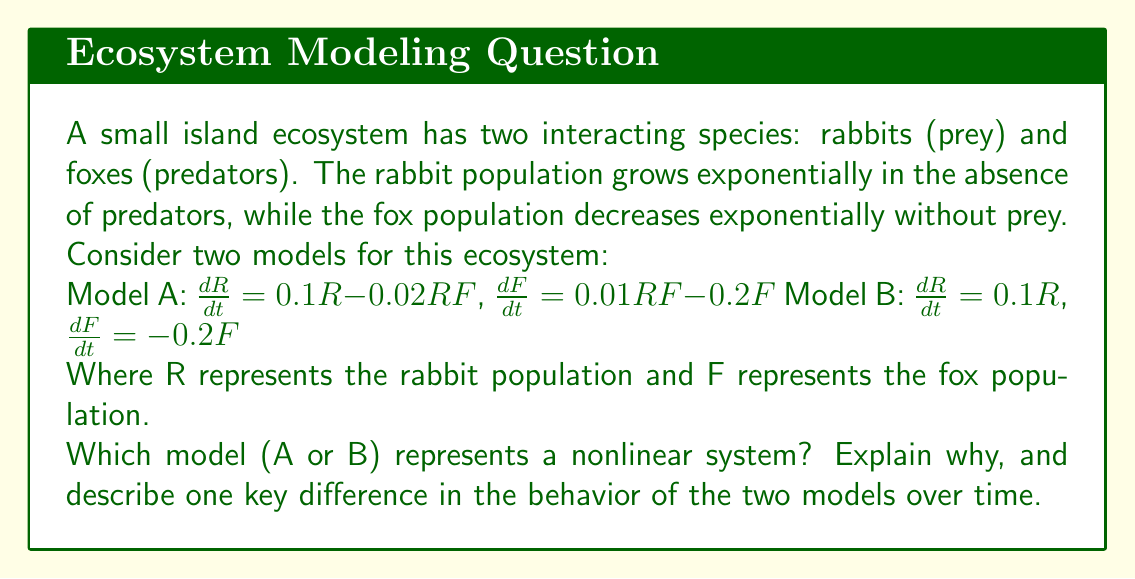Can you answer this question? To answer this question, let's analyze both models:

1. Model A:
   $\frac{dR}{dt} = 0.1R - 0.02RF$
   $\frac{dF}{dt} = 0.01RF - 0.2F$

   This system is nonlinear because it contains terms where variables are multiplied together (RF). The presence of these nonlinear terms makes the system more complex.

2. Model B:
   $\frac{dR}{dt} = 0.1R$
   $\frac{dF}{dt} = -0.2F$

   This system is linear because each equation only contains terms that are proportional to R or F, with no products or higher powers of variables.

Key difference in behavior:

In Model A (nonlinear):
- The rabbit population growth is limited by predation (the -0.02RF term).
- The fox population growth is supported by predation (the 0.01RF term).
- This leads to coupled oscillations in both populations, known as predator-prey cycles.

In Model B (linear):
- The rabbit population grows exponentially without limit.
- The fox population declines exponentially to extinction.
- There is no interaction between the species, leading to unrealistic long-term behavior.

The nonlinear Model A better represents the complexity of real ecological systems, where populations interact and affect each other's growth rates. This model can produce more realistic and dynamic behavior, including equilibrium points and cyclic fluctuations.

In contrast, the linear Model B treats the populations as independent and fails to capture the interdependence of species in an ecosystem. This leads to oversimplified and unrealistic predictions of unchecked growth or decline.
Answer: Model A is nonlinear due to RF terms. It exhibits coupled oscillations, while Model B shows independent exponential growth/decay. 